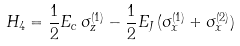Convert formula to latex. <formula><loc_0><loc_0><loc_500><loc_500>H _ { 4 } = { \frac { 1 } { 2 } } E _ { c } \, \sigma _ { z } ^ { ( 1 ) } - { \frac { 1 } { 2 } } E _ { J } \, ( \sigma _ { x } ^ { ( 1 ) } + \sigma _ { x } ^ { ( 2 ) } )</formula> 